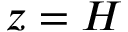Convert formula to latex. <formula><loc_0><loc_0><loc_500><loc_500>z = H</formula> 